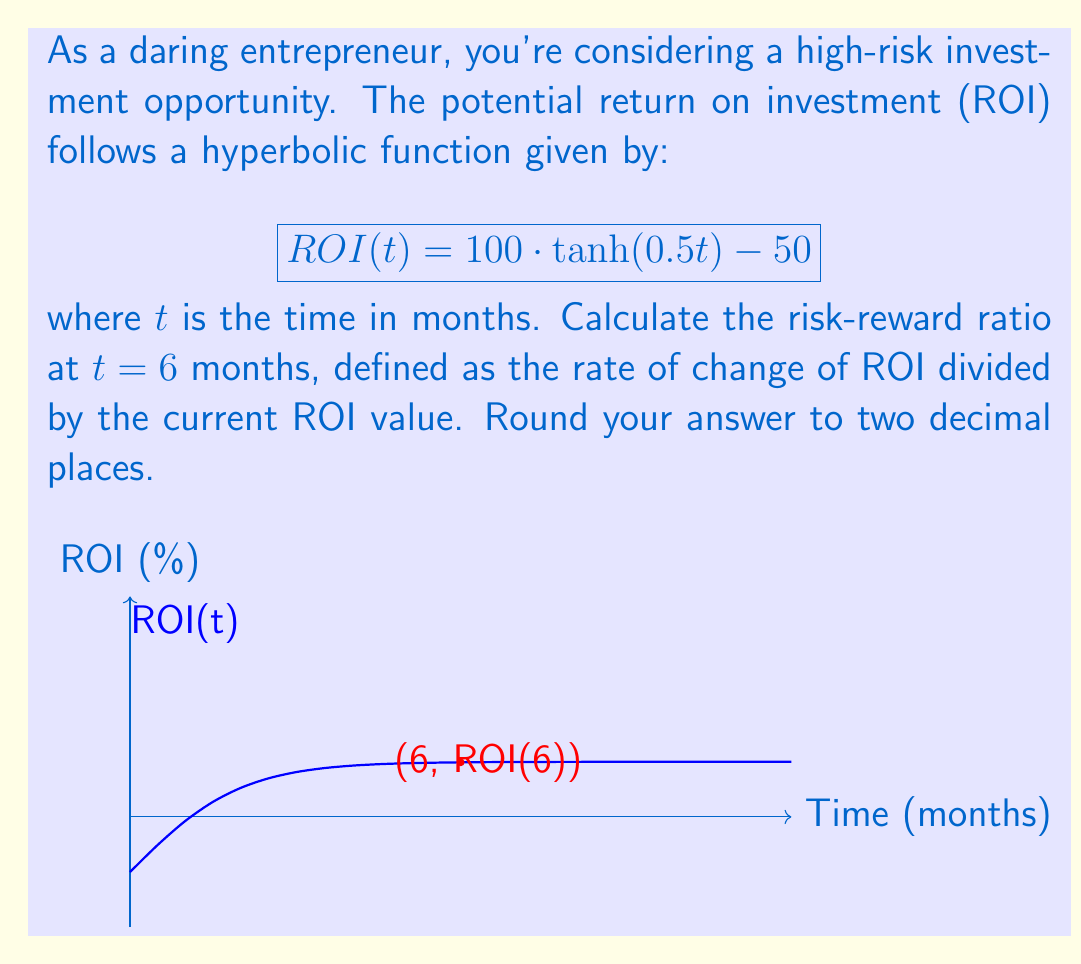Provide a solution to this math problem. Let's approach this step-by-step:

1) First, we need to calculate the ROI at $t = 6$ months:
   $$ROI(6) = 100 \cdot \tanh(0.5 \cdot 6) - 50 = 100 \cdot \tanh(3) - 50$$
   
2) Calculate $\tanh(3)$:
   $$\tanh(3) \approx 0.9951$$
   
3) Now we can compute ROI(6):
   $$ROI(6) = 100 \cdot 0.9951 - 50 \approx 49.51\%$$

4) To find the rate of change of ROI, we need to differentiate ROI(t):
   $$\frac{d}{dt}ROI(t) = 100 \cdot \frac{d}{dt}\tanh(0.5t) = 100 \cdot 0.5 \cdot \text{sech}^2(0.5t)$$

5) Evaluate this at $t = 6$:
   $$\frac{d}{dt}ROI(6) = 50 \cdot \text{sech}^2(3) \approx 50 \cdot (0.0049)^2 \approx 0.1225\%$$

6) The risk-reward ratio is defined as:
   $$\text{Risk-Reward Ratio} = \frac{\text{Rate of Change of ROI}}{\text{Current ROI}}$$

7) Substituting our values:
   $$\text{Risk-Reward Ratio} = \frac{0.1225}{49.51} \approx 0.0025$$

8) Rounding to two decimal places:
   $$\text{Risk-Reward Ratio} \approx 0.00$$
Answer: 0.00 